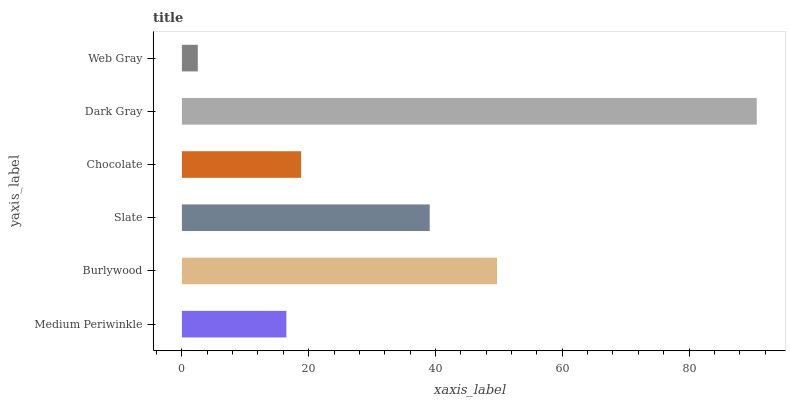Is Web Gray the minimum?
Answer yes or no. Yes. Is Dark Gray the maximum?
Answer yes or no. Yes. Is Burlywood the minimum?
Answer yes or no. No. Is Burlywood the maximum?
Answer yes or no. No. Is Burlywood greater than Medium Periwinkle?
Answer yes or no. Yes. Is Medium Periwinkle less than Burlywood?
Answer yes or no. Yes. Is Medium Periwinkle greater than Burlywood?
Answer yes or no. No. Is Burlywood less than Medium Periwinkle?
Answer yes or no. No. Is Slate the high median?
Answer yes or no. Yes. Is Chocolate the low median?
Answer yes or no. Yes. Is Dark Gray the high median?
Answer yes or no. No. Is Medium Periwinkle the low median?
Answer yes or no. No. 